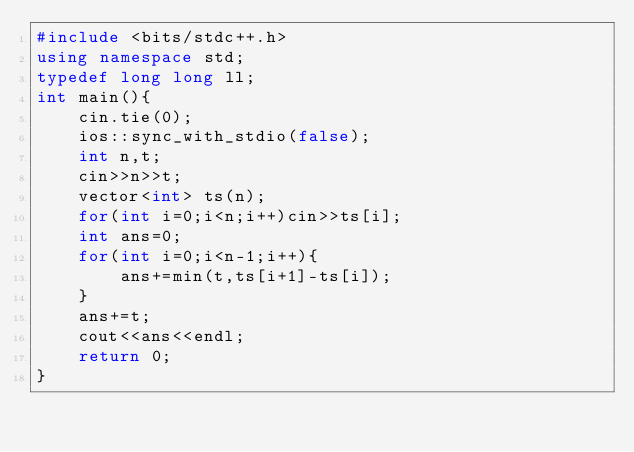<code> <loc_0><loc_0><loc_500><loc_500><_C++_>#include <bits/stdc++.h>
using namespace std;
typedef long long ll;
int main(){
    cin.tie(0);
    ios::sync_with_stdio(false);
    int n,t;
    cin>>n>>t;
    vector<int> ts(n);
    for(int i=0;i<n;i++)cin>>ts[i];
    int ans=0;
    for(int i=0;i<n-1;i++){
        ans+=min(t,ts[i+1]-ts[i]);
    }
    ans+=t;
    cout<<ans<<endl;
    return 0;
}</code> 